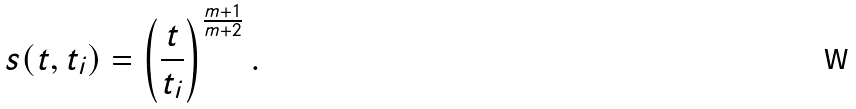Convert formula to latex. <formula><loc_0><loc_0><loc_500><loc_500>s ( t , t _ { i } ) = \left ( \frac { t } { t _ { i } } \right ) ^ { \frac { m + 1 } { m + 2 } } .</formula> 